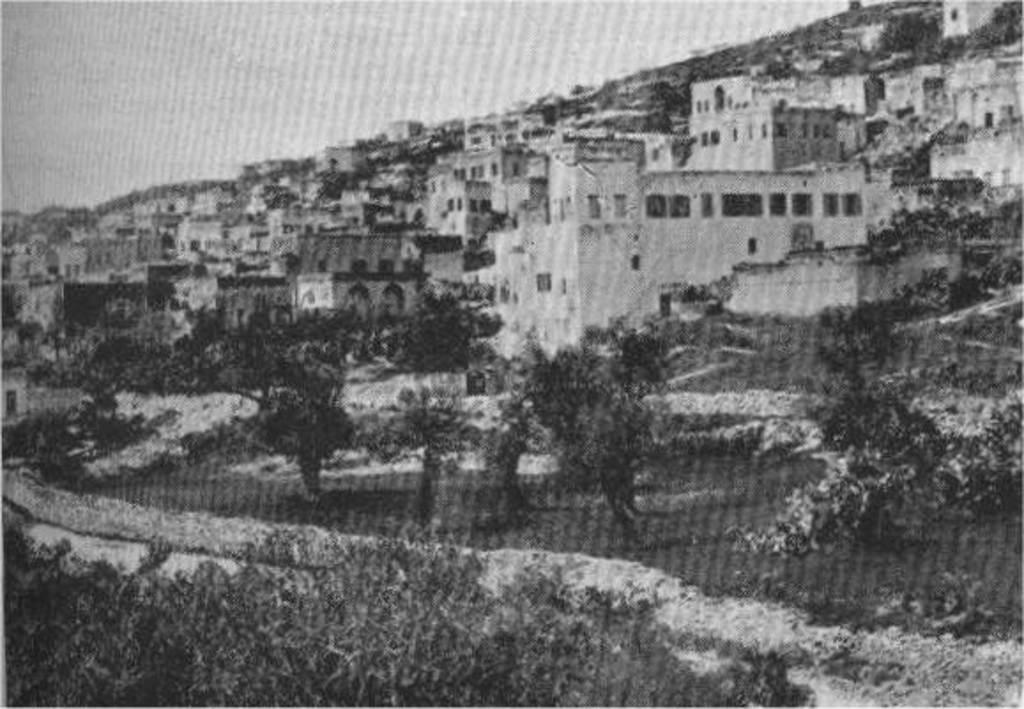What is the main feature of the image's center? The center of the image contains the sky. What type of structures can be seen in the image? There are buildings visible in the image. What architectural elements are present in the buildings? Windows are present in the image. What type of natural elements can be seen in the image? Trees and plants are visible in the image. What type of knife is being used to cut the power in the image? There is no knife or power being cut in the image; it features the sky, buildings, windows, trees, and plants. 